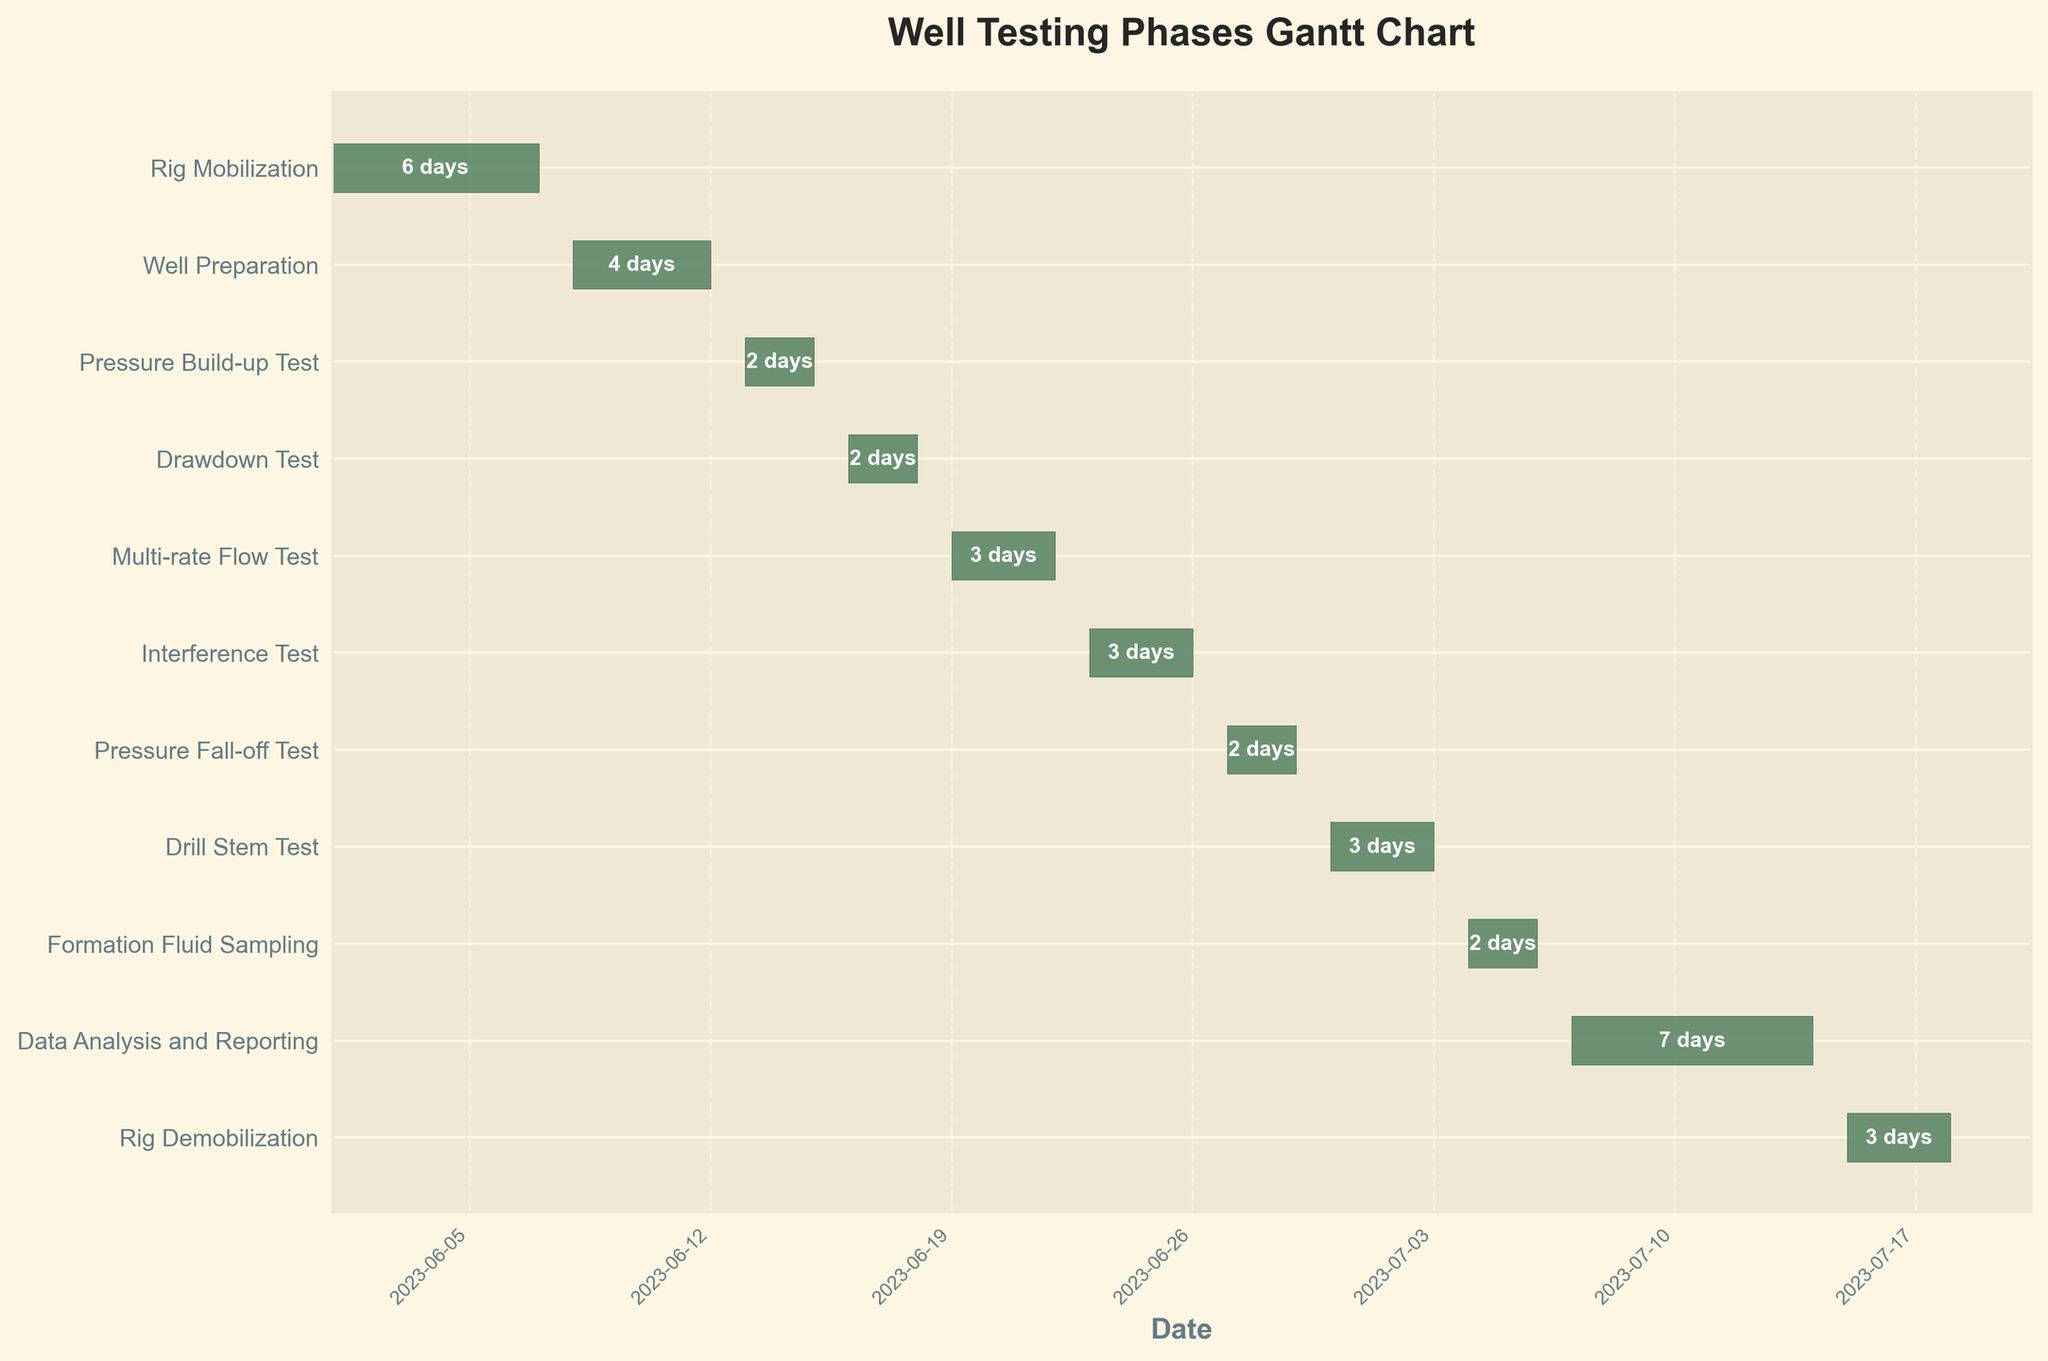What is the title of the Gantt Chart? The title of the Gantt Chart is clearly stated at the top of the figure. It reads as 'Well Testing Phases Gantt Chart'.
Answer: Well Testing Phases Gantt Chart When does the Pressure Build-up Test start and end? The Pressure Build-up Test starts on June 13, 2023, and ends on June 15, 2023. These dates can be found by locating the 'Pressure Build-up Test' task on the y-axis and checking the corresponding start and end dates on the x-axis.
Answer: June 13, 2023 - June 15, 2023 Which phase has the shortest duration? To find the phase with the shortest duration, look for the smallest bar in terms of length. The 'Pressure Build-up Test' runs for 3 days from June 13 to June 15, which is the shortest duration compared to other tasks.
Answer: Pressure Build-up Test What is the total time span from Rig Mobilization to Rig Demobilization? The total time span can be calculated from the start date of the first task (Rig Mobilization on June 1, 2023) to the end date of the last task (Rig Demobilization on July 18, 2023).
Answer: June 1, 2023 - July 18, 2023 How many days are dedicated to Data Analysis and Reporting? The 'Data Analysis and Reporting' phase runs from July 7, 2023, to July 14, 2023. Counting these dates inclusively, the phase spans 8 days.
Answer: 8 days Which two phases have the same duration, and what is that duration? The 'Drawdown Test' and 'Pressure Fall-off Test' both have a duration of 3 days. This can be determined by checking the lengths of the bars and the duration labels next to these tasks.
Answer: Drawdown Test and Pressure Fall-off Test, 3 days How long is the Multi-rate Flow Test compared to the Interference Test? The Multi-rate Flow Test lasts for 4 days (June 19 to June 22) while the Interference Test also lasts for 4 days (June 23 to June 26). Thus, both tests have the same duration.
Answer: 4 days each Which phase immediately follows the Well Preparation phase? By following the y-axis sequentially, the phase that immediately follows 'Well Preparation' is 'Pressure Build-up Test'.
Answer: Pressure Build-up Test If the Data Analysis and Reporting phase could be extended by 3 additional days, what would be its new end date? The 'Data Analysis and Reporting' phase currently ends on July 14, 2023. If extended by 3 additional days, the new end date would be July 17, 2023.
Answer: July 17, 2023 What is the total duration (in days) for all well testing phases combined from Rig Mobilization to Rig Demobilization? To find the total duration, count the days from June 1, 2023, to July 18, 2023. This spans 48 days.
Answer: 48 days 